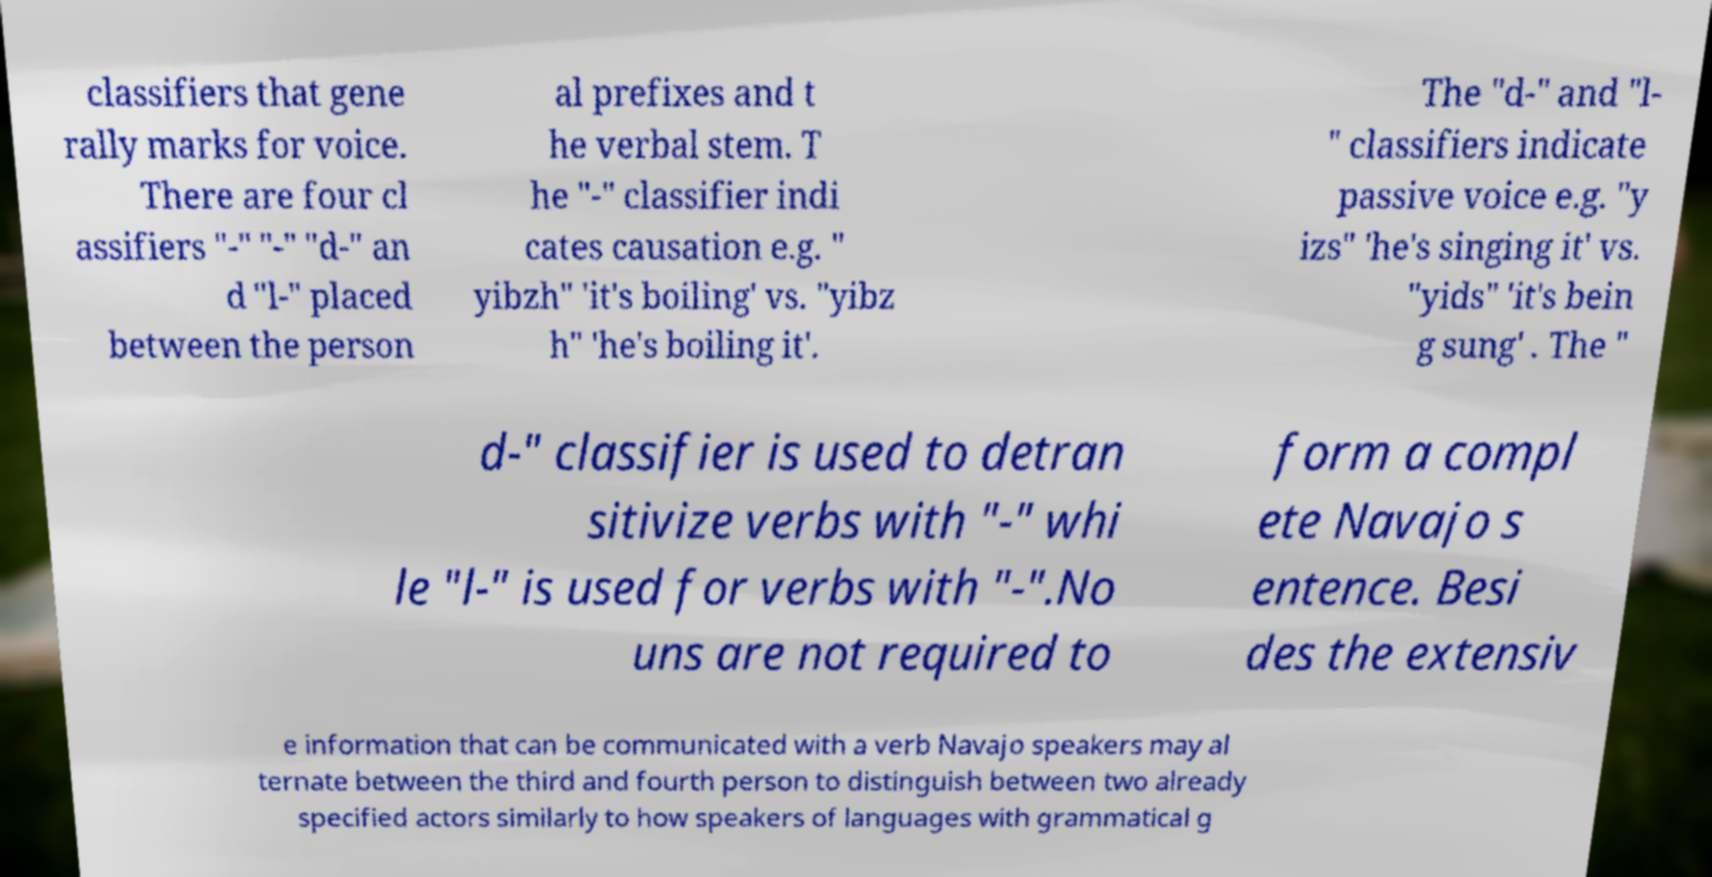Could you assist in decoding the text presented in this image and type it out clearly? classifiers that gene rally marks for voice. There are four cl assifiers "-" "-" "d-" an d "l-" placed between the person al prefixes and t he verbal stem. T he "-" classifier indi cates causation e.g. " yibzh" 'it's boiling' vs. "yibz h" 'he's boiling it'. The "d-" and "l- " classifiers indicate passive voice e.g. "y izs" 'he's singing it' vs. "yids" 'it's bein g sung' . The " d-" classifier is used to detran sitivize verbs with "-" whi le "l-" is used for verbs with "-".No uns are not required to form a compl ete Navajo s entence. Besi des the extensiv e information that can be communicated with a verb Navajo speakers may al ternate between the third and fourth person to distinguish between two already specified actors similarly to how speakers of languages with grammatical g 